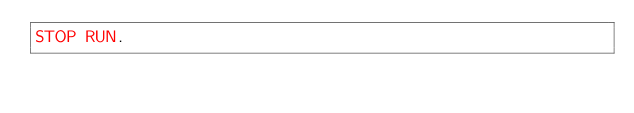Convert code to text. <code><loc_0><loc_0><loc_500><loc_500><_COBOL_>STOP RUN.
</code> 